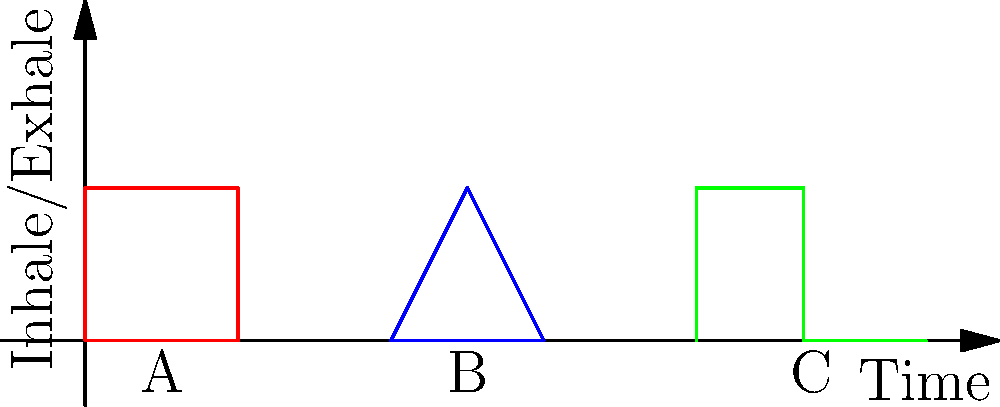Which breathing pattern diagram is most effective for rapid stress reduction in high-pressure situations? To determine the most effective breathing pattern for rapid stress reduction, let's analyze each pattern:

1. Pattern A (Square breathing):
   - Equal duration for inhale, hold, exhale, and hold
   - Balanced and easy to remember
   - Provides a steady rhythm but may not be ideal for quick stress relief

2. Pattern B (Triangle breathing):
   - Continuous flow without holds
   - Simple pattern but may not provide enough depth for stress reduction

3. Pattern C (4-7-8 breathing):
   - Short inhale (4 counts)
   - Longer hold (7 counts)
   - Even longer exhale (8 counts)
   - Emphasizes exhale, which activates the parasympathetic nervous system

The 4-7-8 breathing pattern (C) is most effective for rapid stress reduction because:
1. The quick inhale prevents hyperventilation
2. The hold allows for increased oxygen absorption
3. The extended exhale triggers the relaxation response
4. The ratio of inhale to exhale (1:2) helps calm the nervous system quickly

This pattern is particularly useful in high-pressure situations as it can be performed discreetly and provides quick relief.
Answer: Pattern C (4-7-8 breathing) 